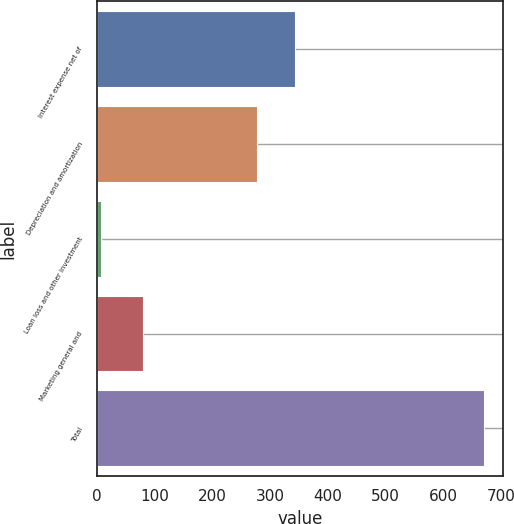Convert chart to OTSL. <chart><loc_0><loc_0><loc_500><loc_500><bar_chart><fcel>Interest expense net of<fcel>Depreciation and amortization<fcel>Loan loss and other investment<fcel>Marketing general and<fcel>Total<nl><fcel>343.6<fcel>277.3<fcel>6.7<fcel>80.1<fcel>669.7<nl></chart> 